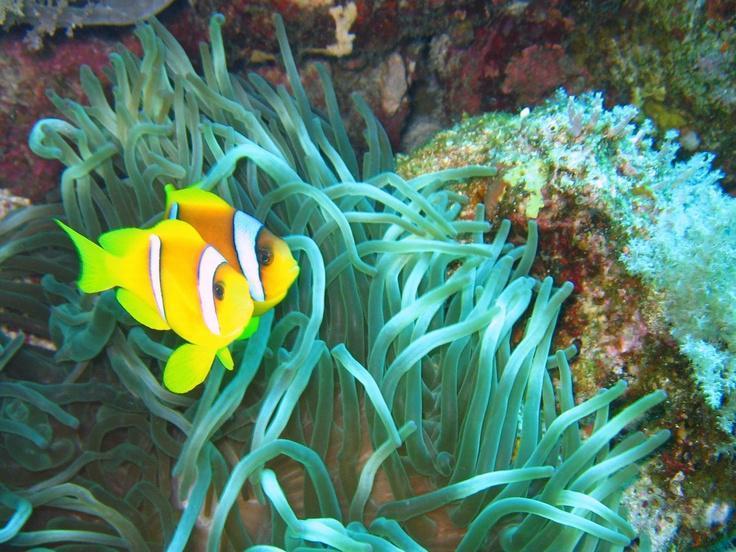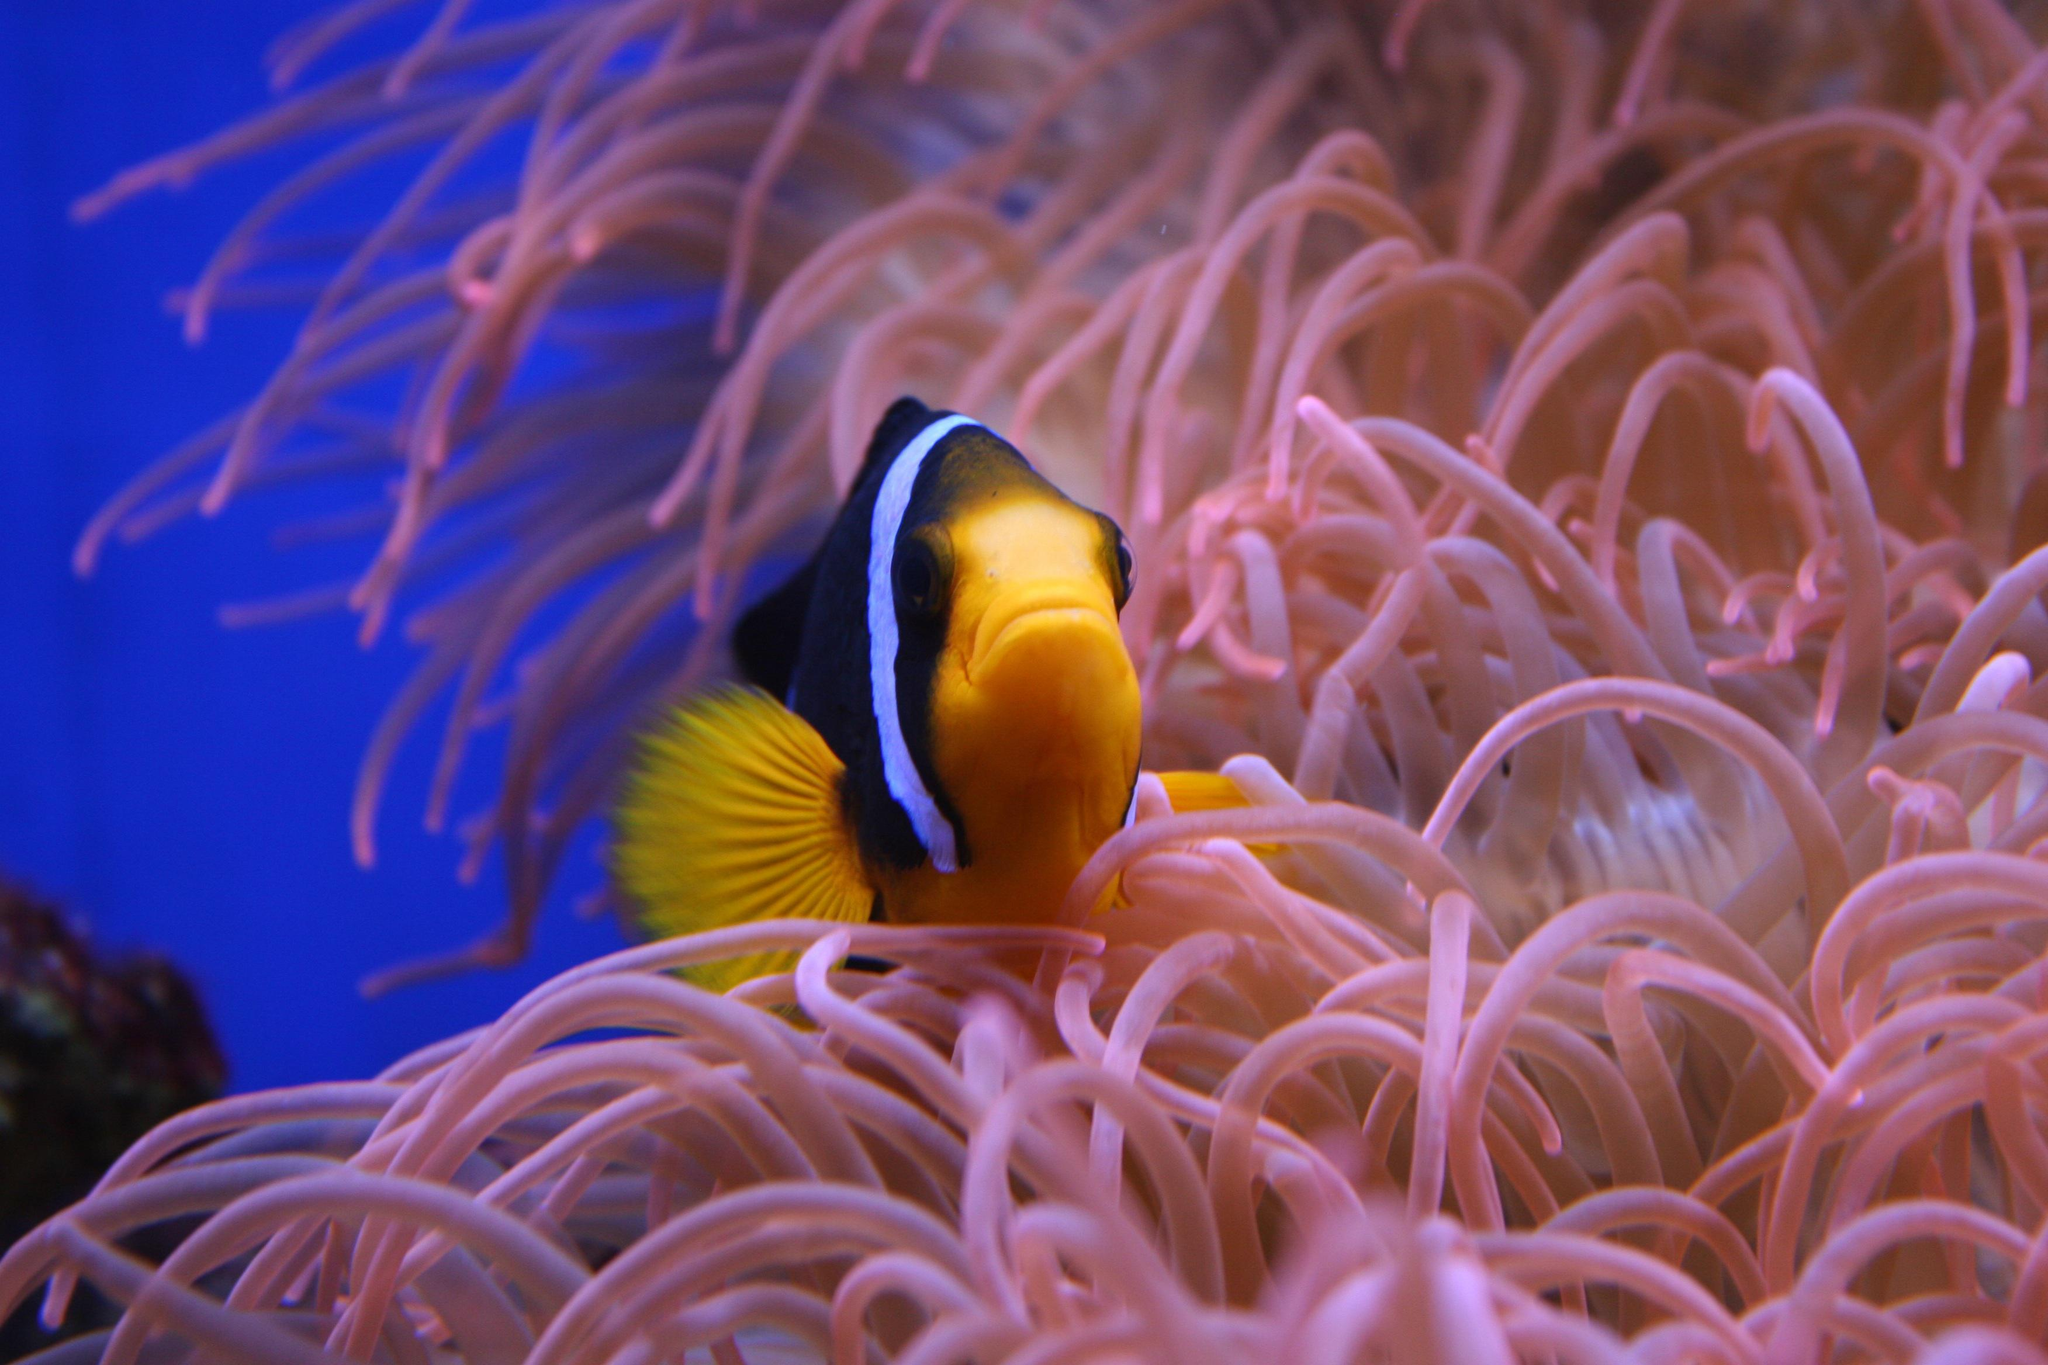The first image is the image on the left, the second image is the image on the right. Examine the images to the left and right. Is the description "there is one clownfish facing right on the right image" accurate? Answer yes or no. No. 